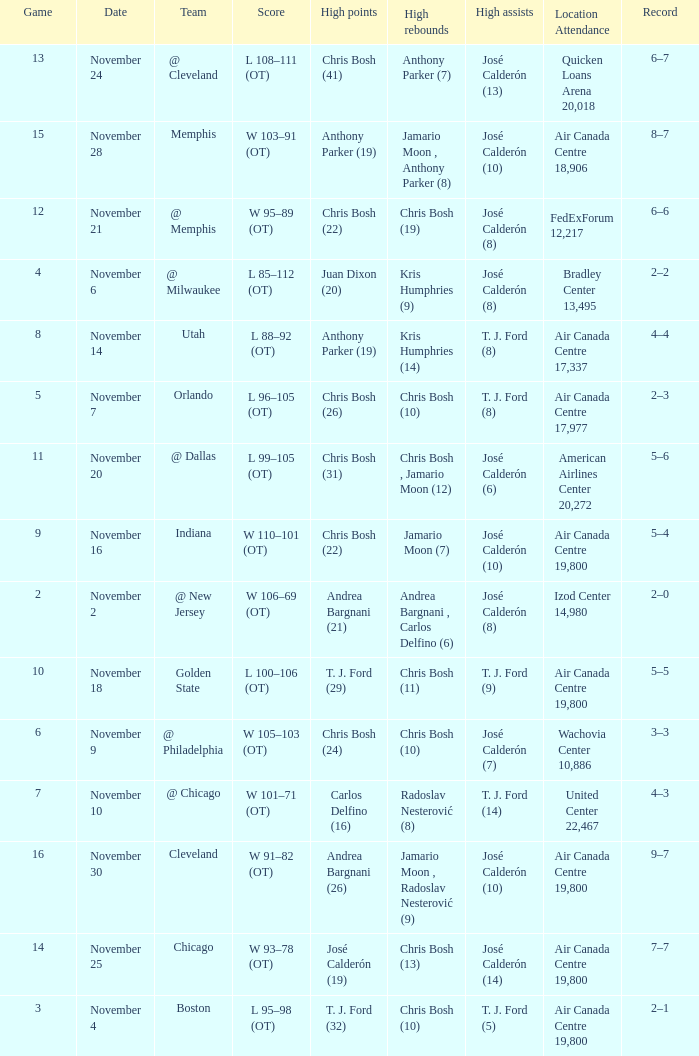What is the score when the team is @ cleveland? L 108–111 (OT). 